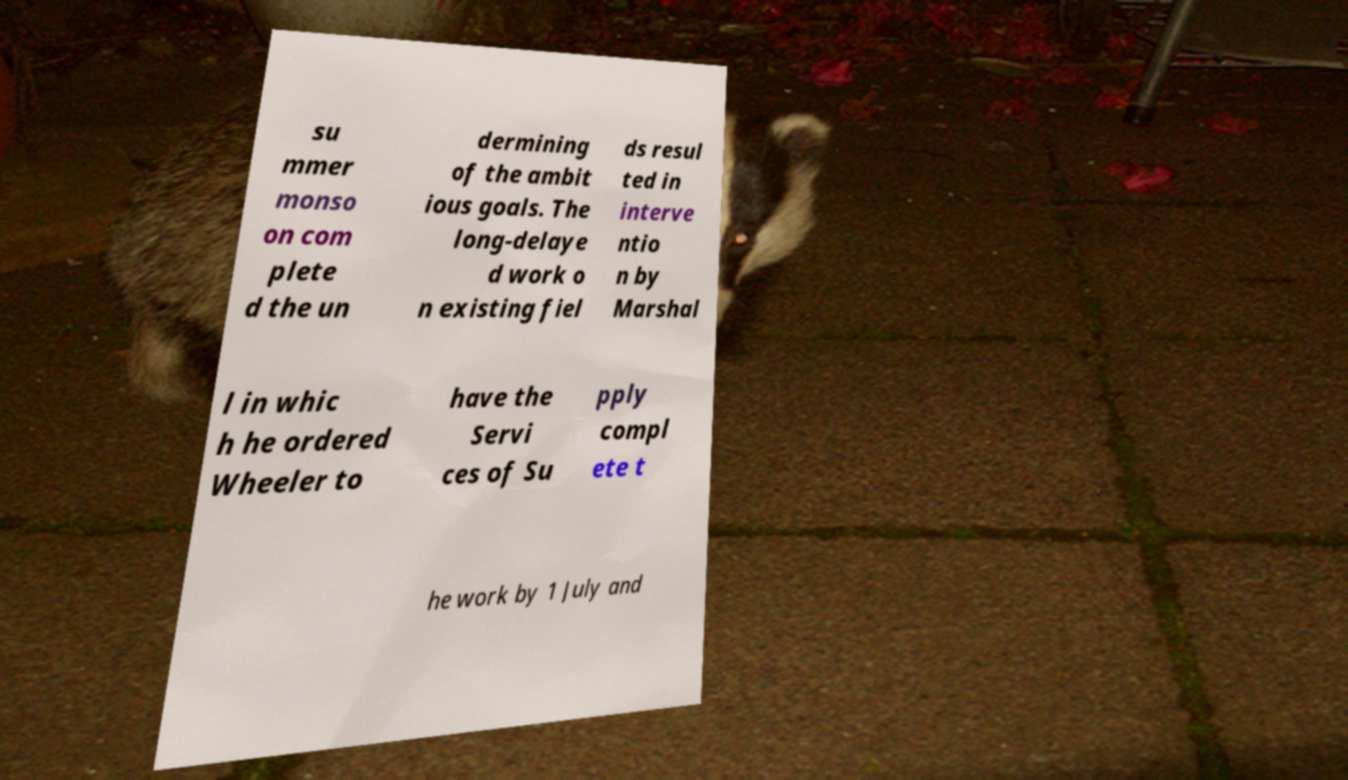Can you read and provide the text displayed in the image?This photo seems to have some interesting text. Can you extract and type it out for me? su mmer monso on com plete d the un dermining of the ambit ious goals. The long-delaye d work o n existing fiel ds resul ted in interve ntio n by Marshal l in whic h he ordered Wheeler to have the Servi ces of Su pply compl ete t he work by 1 July and 